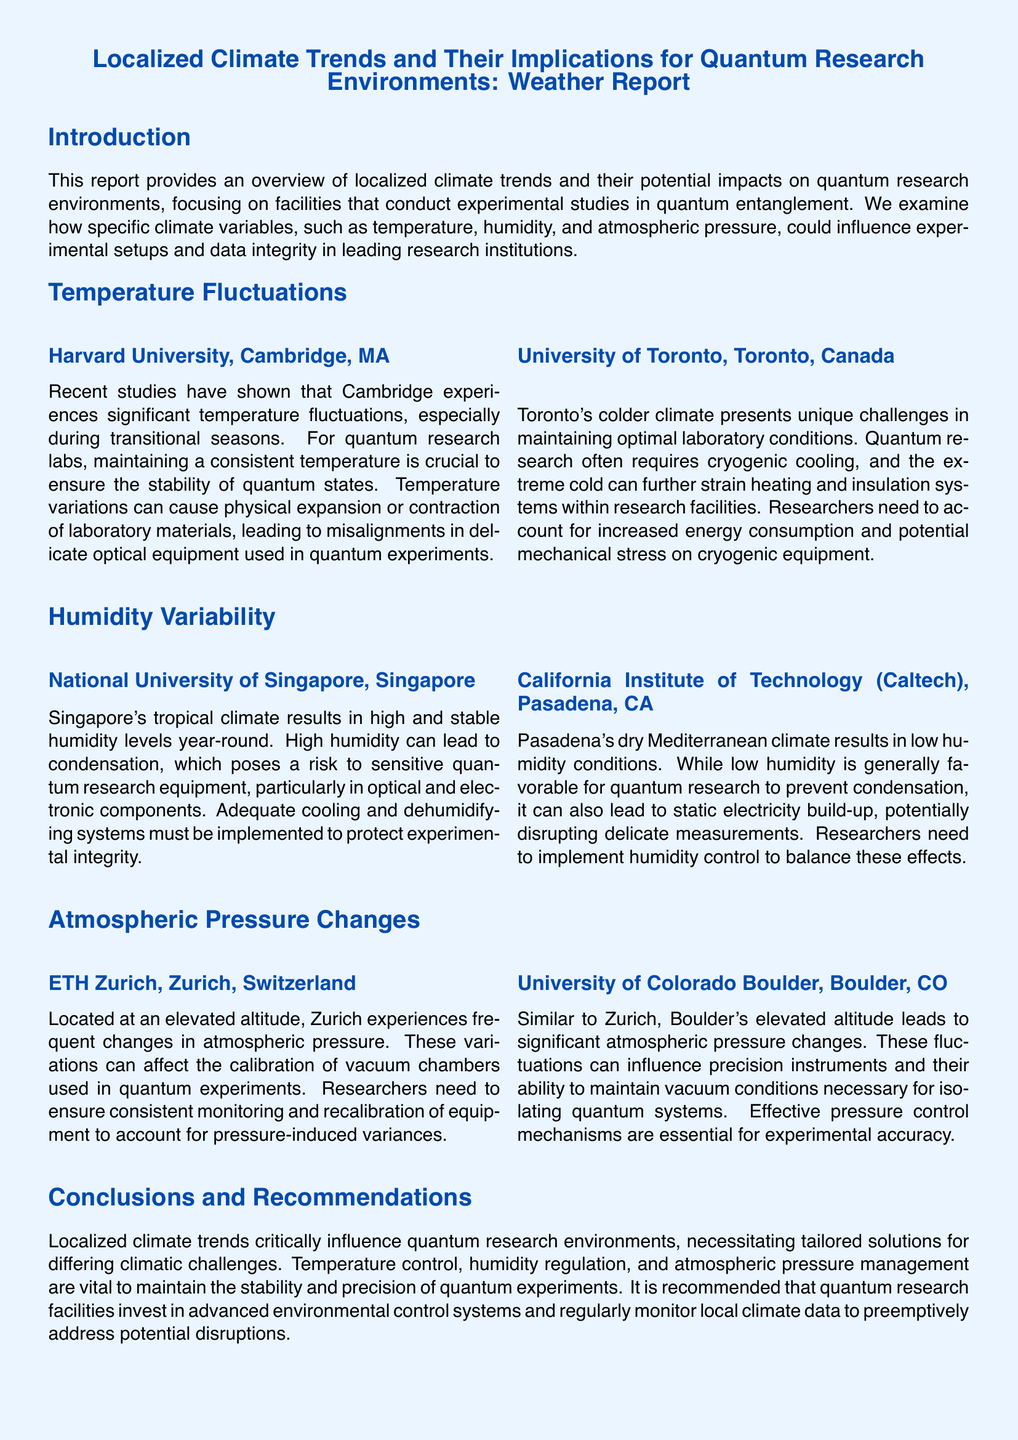What is the main focus of this report? The report focuses on localized climate trends and their impacts on quantum research environments, particularly in experimental studies of quantum entanglement.
Answer: Localized climate trends and their impacts on quantum research environments What temperature-related challenge is noted for Harvard University? The report states that temperature fluctuations in Cambridge can cause misalignments in delicate optical equipment used in quantum experiments.
Answer: Misalignments in delicate optical equipment What issue arises due to Singapore's climate? The high humidity levels year-round in Singapore can lead to condensation, risking sensitive quantum research equipment.
Answer: Condensation What is a consequence of Toronto's colder climate for quantum research? The extreme cold in Toronto can strain heating and insulation systems within research facilities.
Answer: Strain on heating and insulation systems What must be implemented in Pasadena due to low humidity? Researchers need to implement humidity control to balance the effects of low humidity, which can cause static electricity build-up.
Answer: Humidity control How often does ETH Zurich experience pressure changes? The report indicates that Zurich experiences frequent changes in atmospheric pressure due to its elevated altitude.
Answer: Frequent changes What is recommended for quantum research facilities? The report recommends that quantum research facilities invest in advanced environmental control systems and regularly monitor local climate data.
Answer: Invest in advanced environmental control systems What climatic factor is important for maintaining vacuum conditions in Boulder? Atmospheric pressure management is essential in Boulder due to its elevated altitude affecting precision instruments.
Answer: Atmospheric pressure management How does the document categorize the implications of localized climate trends? The document categorizes the implications as vital for maintaining stability and precision in quantum experiments.
Answer: Vital for maintaining stability and precision 